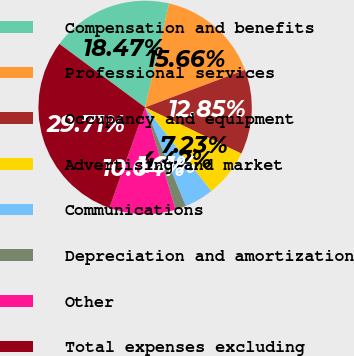Convert chart to OTSL. <chart><loc_0><loc_0><loc_500><loc_500><pie_chart><fcel>Compensation and benefits<fcel>Professional services<fcel>Occupancy and equipment<fcel>Advertising and market<fcel>Communications<fcel>Depreciation and amortization<fcel>Other<fcel>Total expenses excluding<nl><fcel>18.47%<fcel>15.66%<fcel>12.85%<fcel>7.23%<fcel>4.42%<fcel>1.61%<fcel>10.04%<fcel>29.71%<nl></chart> 